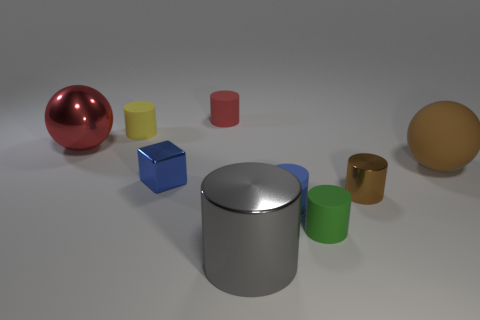What could be the purpose of these objects if they were real? If these objects were real, they might serve various practical purposes. For example, the cylinders and cubes could be containers or building components. Their simple geometric shapes suggest functional design, possibly for storage, stacking, or as parts of larger assemblies in industrial or architectural contexts. 